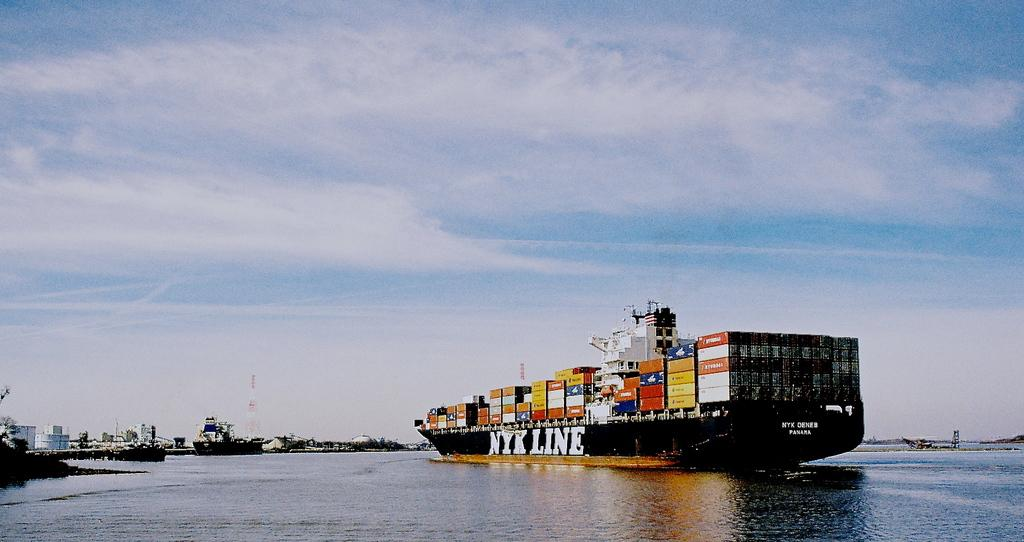What is in the water in the image? A: There are ships in the water in the image. What can be seen on the ships? The ships have containers and other objects on them. What is visible in the background of the image? There is a tower and trees in the background of the image. What part of the natural environment is visible in the image? The sky is visible in the background of the image. What type of lock can be seen on the stomach of the person in the image? There is no person or lock present in the image; it features ships in the water with containers and other objects on them, as well as a background with a tower, trees, and the sky. 